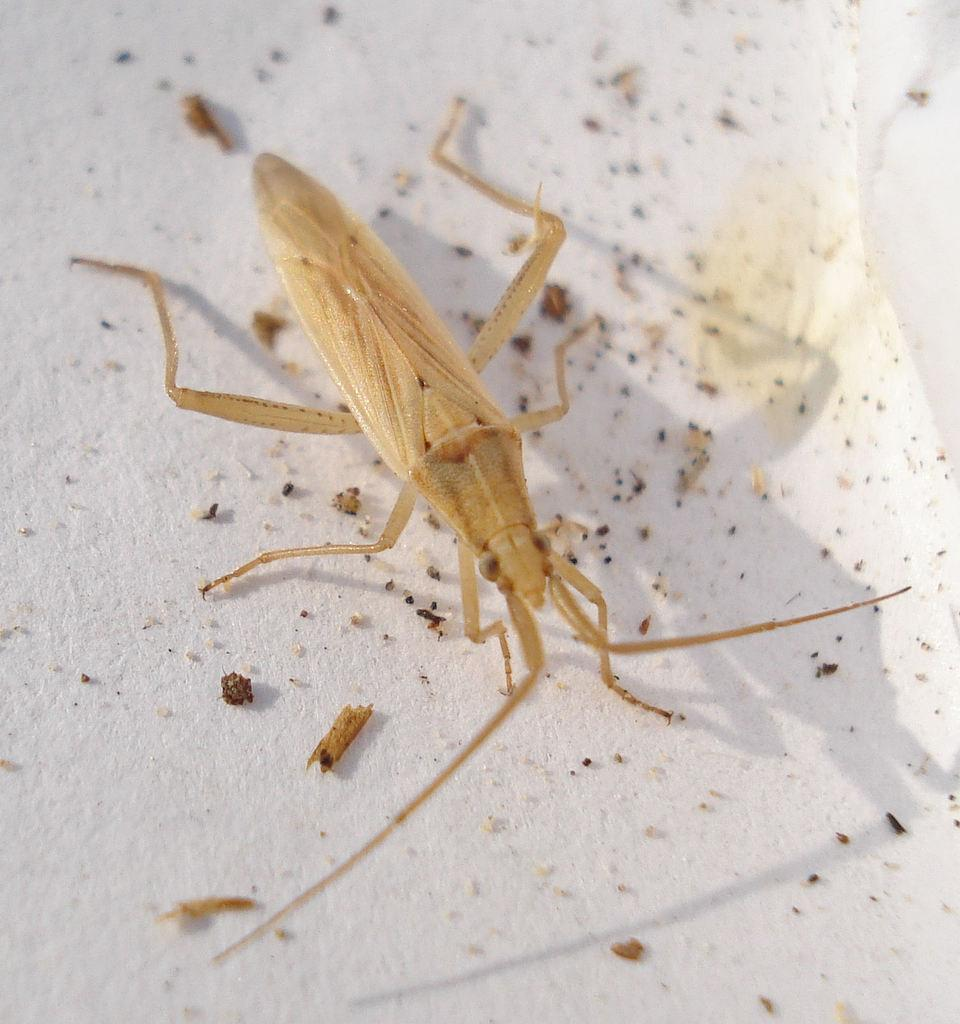What type of creature is present in the image? There is an insect in the image. What is the insect situated on in the image? The insect is on a white surface. What type of steam can be seen coming from the insect in the image? There is no steam present in the image, as it features an insect on a white surface. 